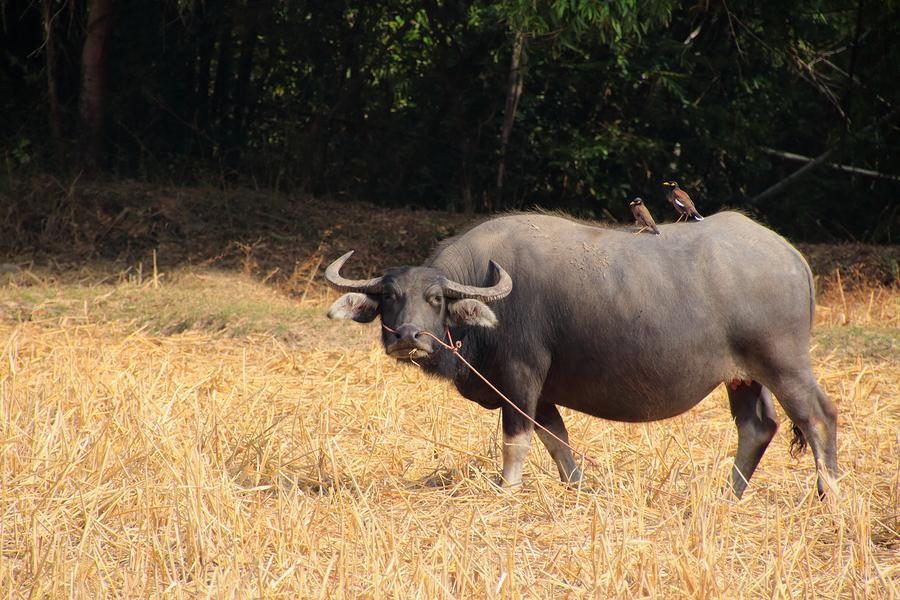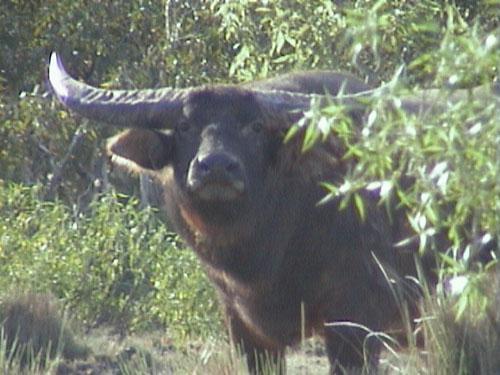The first image is the image on the left, the second image is the image on the right. Considering the images on both sides, is "There is only one bull facing left in the left image." valid? Answer yes or no. Yes. The first image is the image on the left, the second image is the image on the right. Assess this claim about the two images: "Both images have only one dark bull each.". Correct or not? Answer yes or no. Yes. 